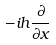Convert formula to latex. <formula><loc_0><loc_0><loc_500><loc_500>- i h \frac { \partial } { \partial x }</formula> 